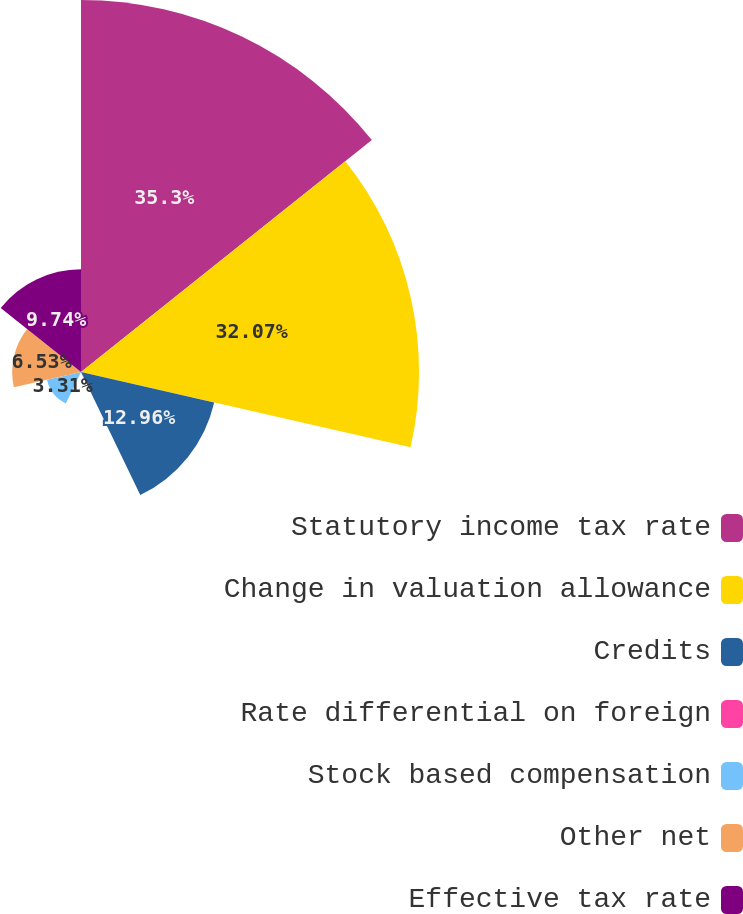Convert chart to OTSL. <chart><loc_0><loc_0><loc_500><loc_500><pie_chart><fcel>Statutory income tax rate<fcel>Change in valuation allowance<fcel>Credits<fcel>Rate differential on foreign<fcel>Stock based compensation<fcel>Other net<fcel>Effective tax rate<nl><fcel>35.29%<fcel>32.07%<fcel>12.96%<fcel>0.09%<fcel>3.31%<fcel>6.53%<fcel>9.74%<nl></chart> 